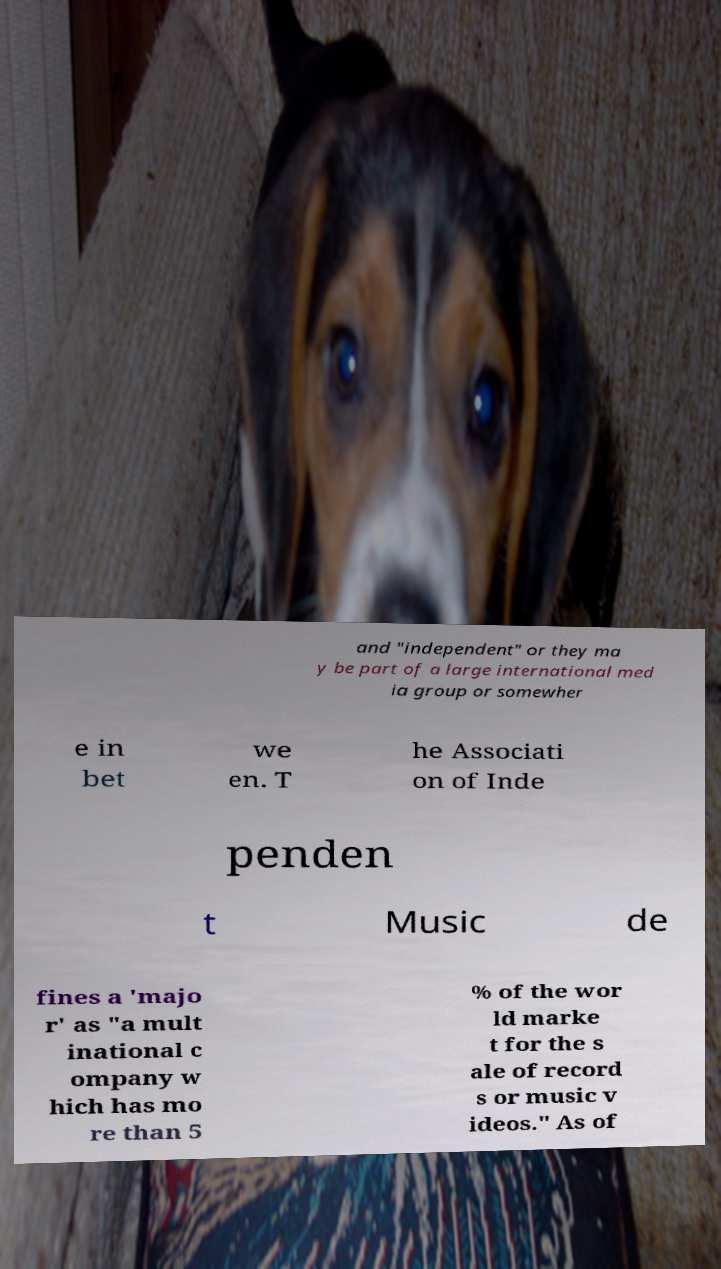There's text embedded in this image that I need extracted. Can you transcribe it verbatim? and "independent" or they ma y be part of a large international med ia group or somewher e in bet we en. T he Associati on of Inde penden t Music de fines a 'majo r' as "a mult inational c ompany w hich has mo re than 5 % of the wor ld marke t for the s ale of record s or music v ideos." As of 